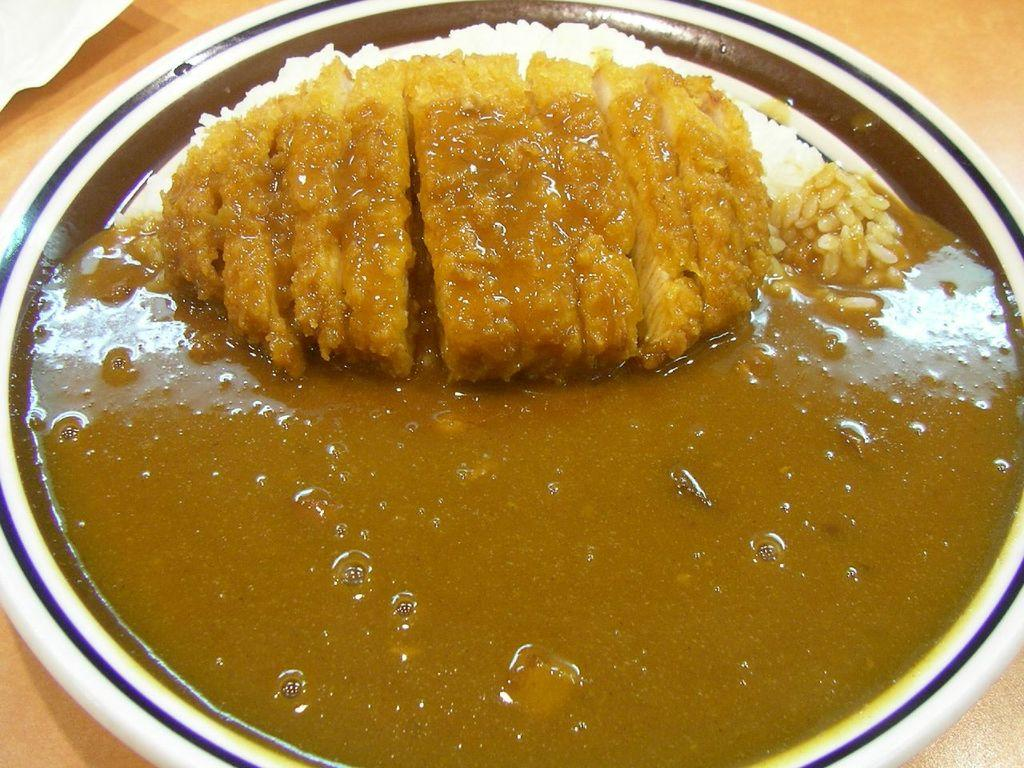What is on the plate that is visible in the image? There is a plate with food in the image. What type of food can be seen on the plate? The food includes rice. Where is the plate located in the image? The plate is on a table. What type of writing can be seen on the plate in the image? There is no writing visible on the plate in the image. Is there a rabbit sitting next to the plate in the image? There is no rabbit present in the image. 